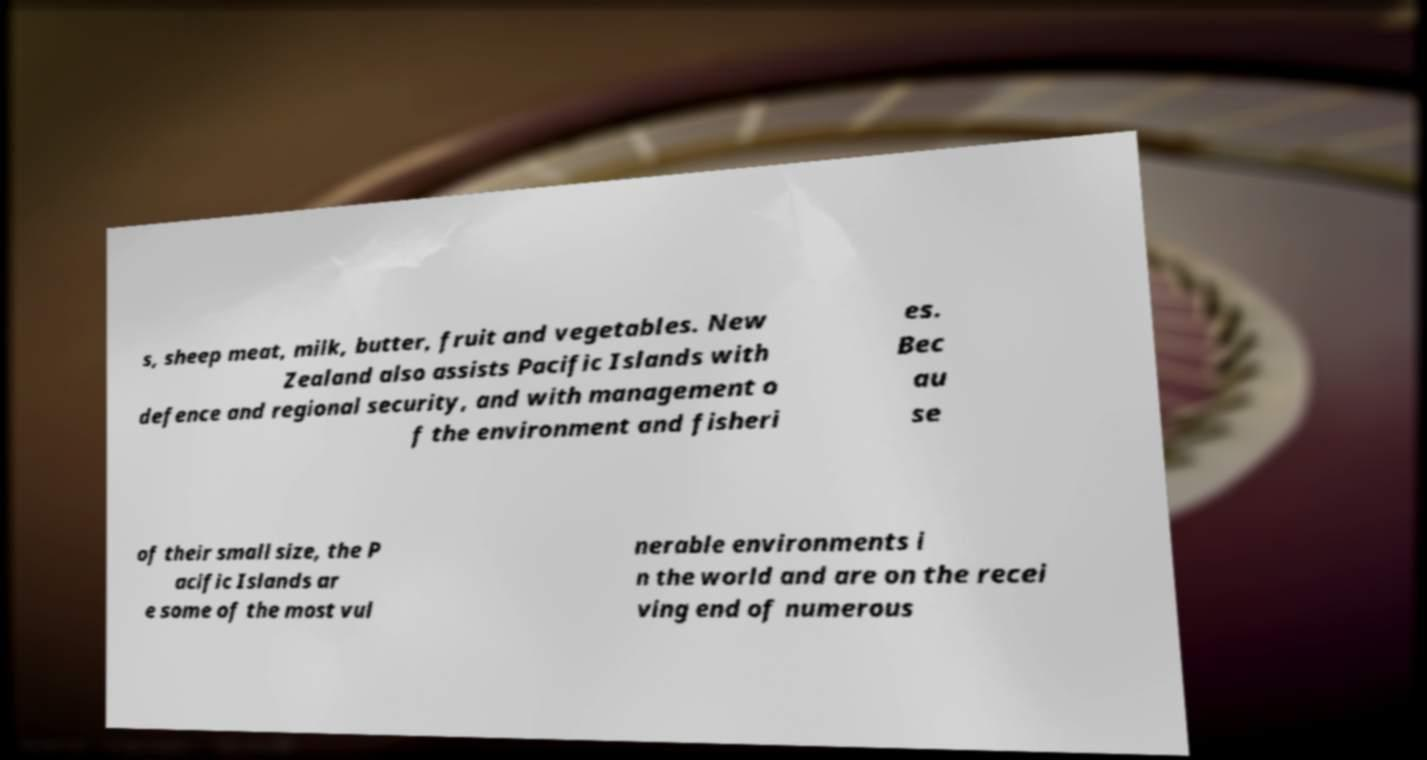I need the written content from this picture converted into text. Can you do that? s, sheep meat, milk, butter, fruit and vegetables. New Zealand also assists Pacific Islands with defence and regional security, and with management o f the environment and fisheri es. Bec au se of their small size, the P acific Islands ar e some of the most vul nerable environments i n the world and are on the recei ving end of numerous 